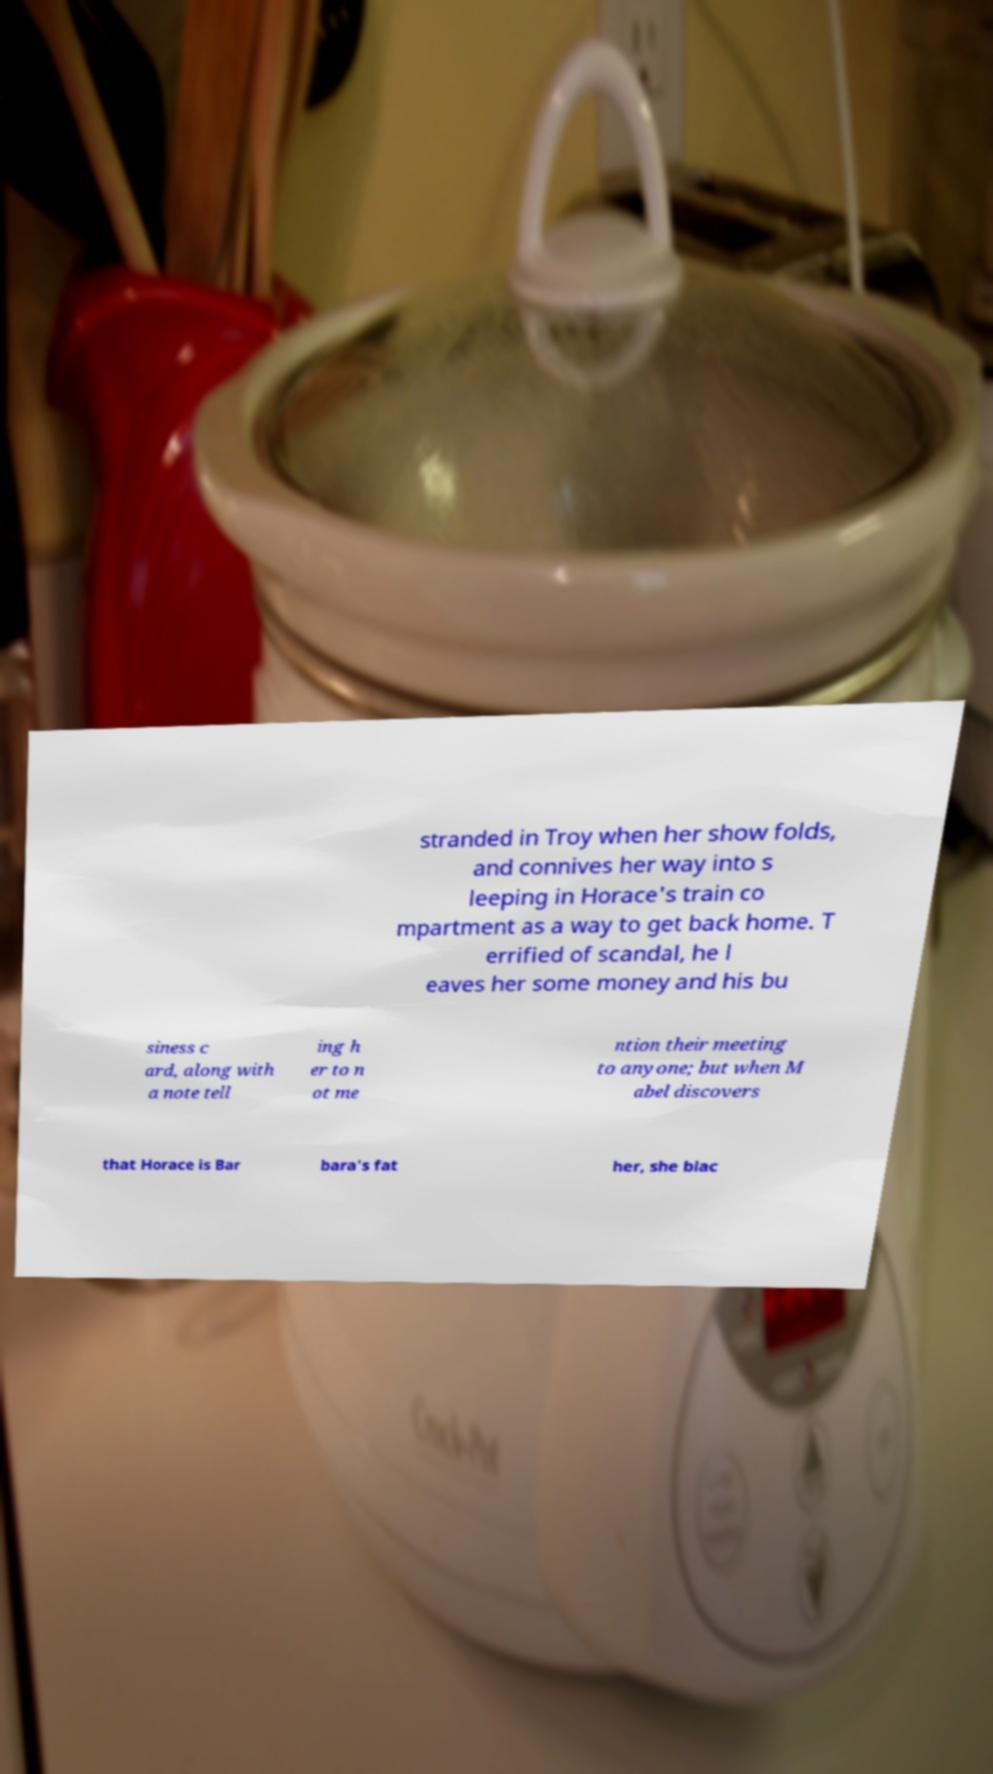There's text embedded in this image that I need extracted. Can you transcribe it verbatim? stranded in Troy when her show folds, and connives her way into s leeping in Horace's train co mpartment as a way to get back home. T errified of scandal, he l eaves her some money and his bu siness c ard, along with a note tell ing h er to n ot me ntion their meeting to anyone; but when M abel discovers that Horace is Bar bara's fat her, she blac 